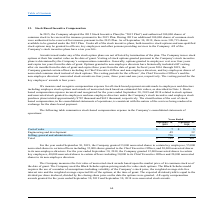According to Csp's financial document, How many nonvested shares did the company grant to key employees for the year ended September 30, 2019? According to the financial document, 33,000. The relevant text states: "ear ended September 30, 2019, the Company granted 33,000 nonvested shares to certain key employees, 55,000..." Also, How does the company measure the value of the nonvested stock awards? Based upon the market price of its common stock as of the date of grant.. The document states: "measures the fair value of nonvested stock awards based upon the market price of its common stock as of the date of grant. The Company used the Black-..." Also, What is the total stock based compensation expense incurred for the year ended September 30, 2019? According to the financial document, $792 (in thousands). The relevant text states: "mployee stock purchase plans totaled approximately $792 thousand and $691 thousand, respectively. The classification of the cost of stock- based compensatio..." Also, can you calculate: What percentage of the total stock based compensation is spent on the cost of sales? Based on the calculation: $7/$792 , the result is 0.88 (percentage). This is based on the information: "loyee stock purchase plans totaled approximately $792 thousand and $691 thousand, respectively. The classification of the cost of stock- based compensati loyee stock purchase plans totaled approximate..." The key data points involved are: 7, 792. Also, can you calculate: What is the percentage increase in the stock based compensation expense on cost of sales? To answer this question, I need to perform calculations using the financial data. The calculation is: (7-5)/5 , which equals 40 (percentage). This is based on the information: "15 Plan. As of September 30, 2019, there were 320,715 shares available to be granted under the 2015 Plan. Under all of the stock incentive plans, both In 2015, the Company adopted the 2015 Stock Incen..." The key data points involved are: 5, 7. Also, can you calculate: What is the total stock based compensation expense on non-cost of sales related activities? Based on the calculation: 792 - 7 , the result is 785 (in thousands). This is based on the information: "loyee stock purchase plans totaled approximately $792 thousand and $691 thousand, respectively. The classification of the cost of stock- based compensati loyee stock purchase plans totaled approximate..." The key data points involved are: 792. 